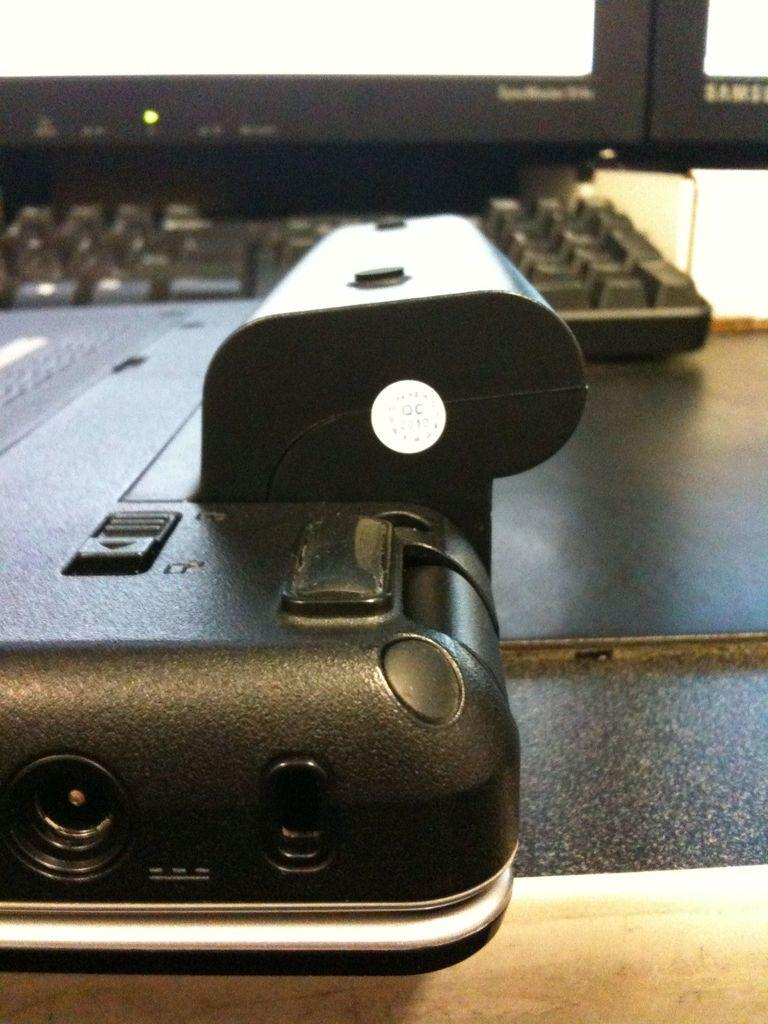What type of furniture is visible in the image? There is a table in the image. What can be found on the table? There are objects on the table, including a keyboard. What type of metal is the boy's hands made of in the image? There is no boy or mention of hands made of metal in the image. 